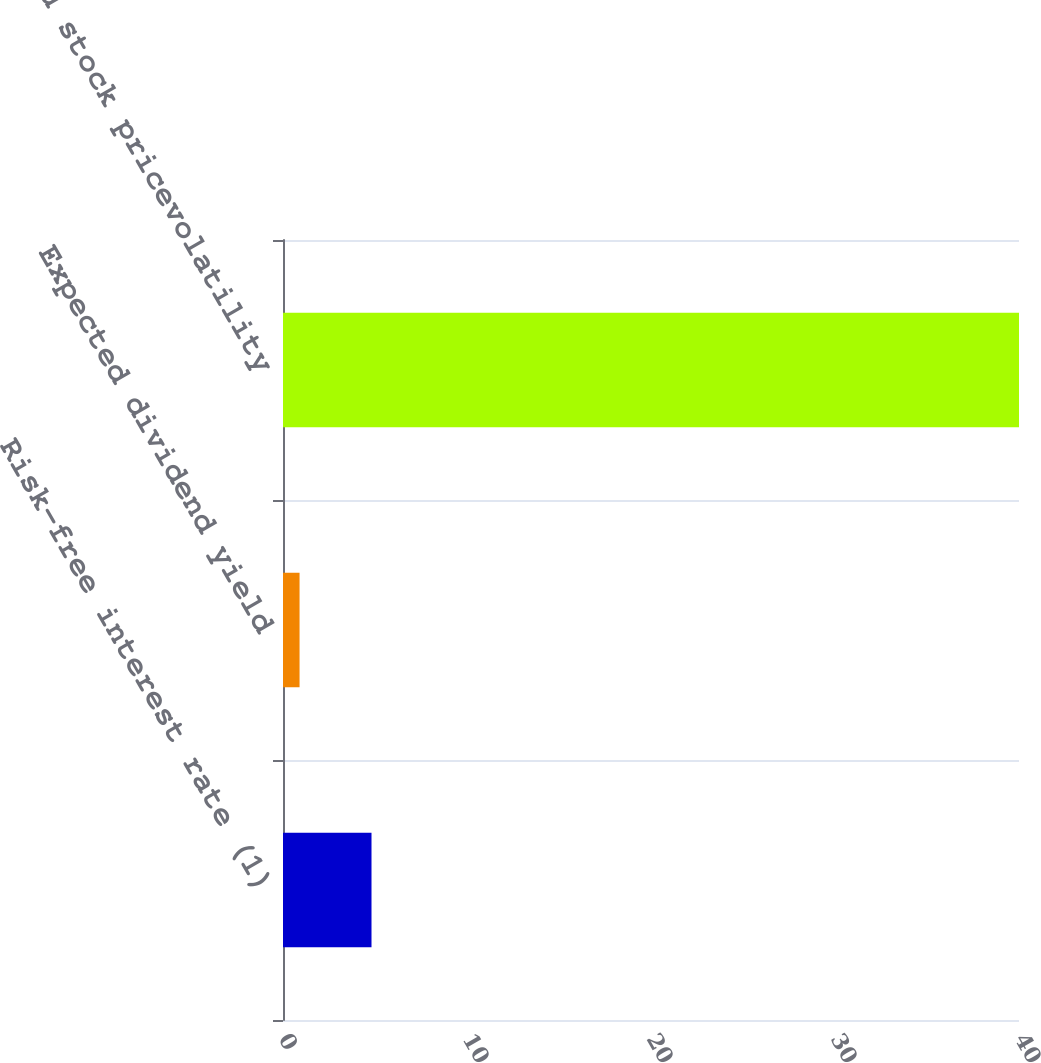Convert chart to OTSL. <chart><loc_0><loc_0><loc_500><loc_500><bar_chart><fcel>Risk-free interest rate (1)<fcel>Expected dividend yield<fcel>Expected stock pricevolatility<nl><fcel>4.81<fcel>0.9<fcel>40<nl></chart> 